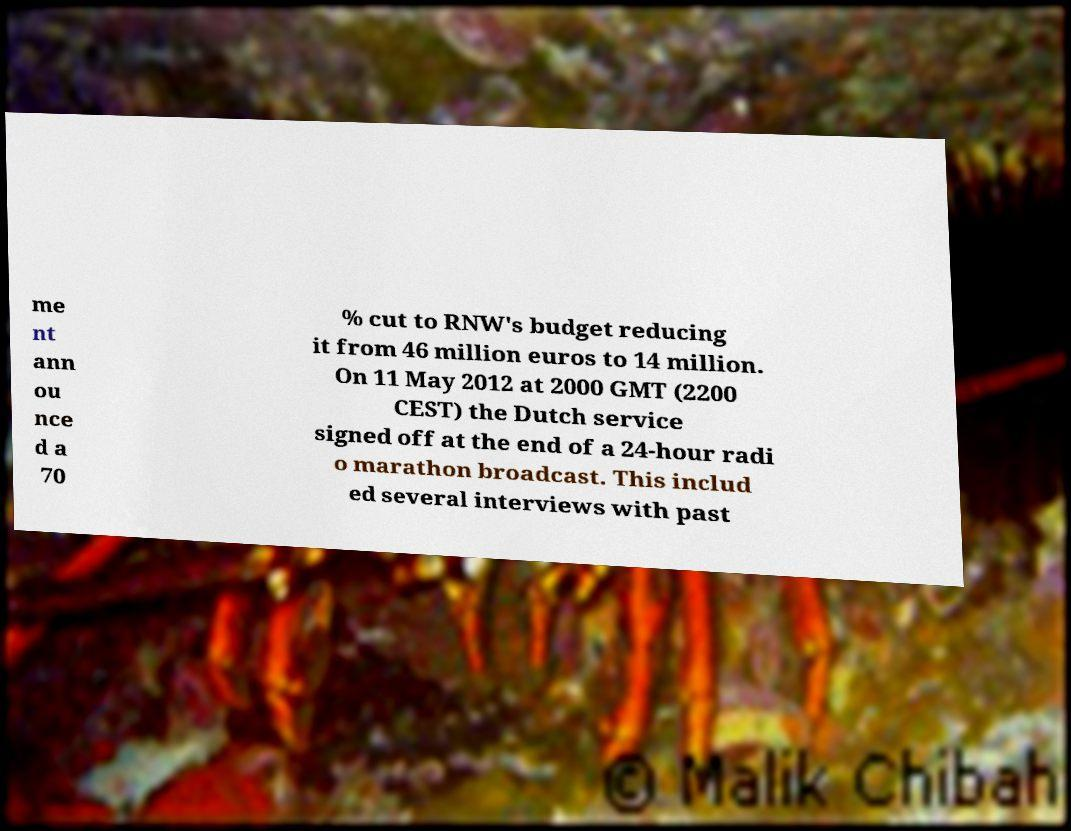I need the written content from this picture converted into text. Can you do that? me nt ann ou nce d a 70 % cut to RNW's budget reducing it from 46 million euros to 14 million. On 11 May 2012 at 2000 GMT (2200 CEST) the Dutch service signed off at the end of a 24-hour radi o marathon broadcast. This includ ed several interviews with past 